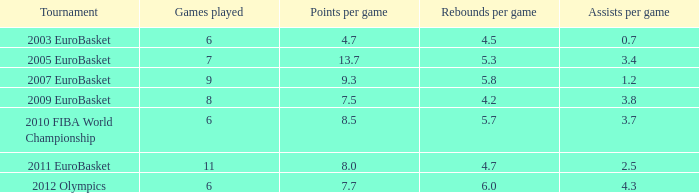Parse the full table. {'header': ['Tournament', 'Games played', 'Points per game', 'Rebounds per game', 'Assists per game'], 'rows': [['2003 EuroBasket', '6', '4.7', '4.5', '0.7'], ['2005 EuroBasket', '7', '13.7', '5.3', '3.4'], ['2007 EuroBasket', '9', '9.3', '5.8', '1.2'], ['2009 EuroBasket', '8', '7.5', '4.2', '3.8'], ['2010 FIBA World Championship', '6', '8.5', '5.7', '3.7'], ['2011 EuroBasket', '11', '8.0', '4.7', '2.5'], ['2012 Olympics', '6', '7.7', '6.0', '4.3']]} 7 points per game? 1.0. 